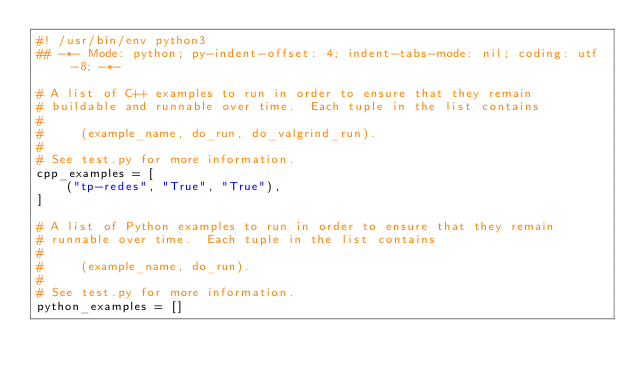<code> <loc_0><loc_0><loc_500><loc_500><_Python_>#! /usr/bin/env python3
## -*- Mode: python; py-indent-offset: 4; indent-tabs-mode: nil; coding: utf-8; -*-

# A list of C++ examples to run in order to ensure that they remain
# buildable and runnable over time.  Each tuple in the list contains
#
#     (example_name, do_run, do_valgrind_run).
#
# See test.py for more information.
cpp_examples = [
    ("tp-redes", "True", "True"),
]

# A list of Python examples to run in order to ensure that they remain
# runnable over time.  Each tuple in the list contains
#
#     (example_name, do_run).
#
# See test.py for more information.
python_examples = []
</code> 